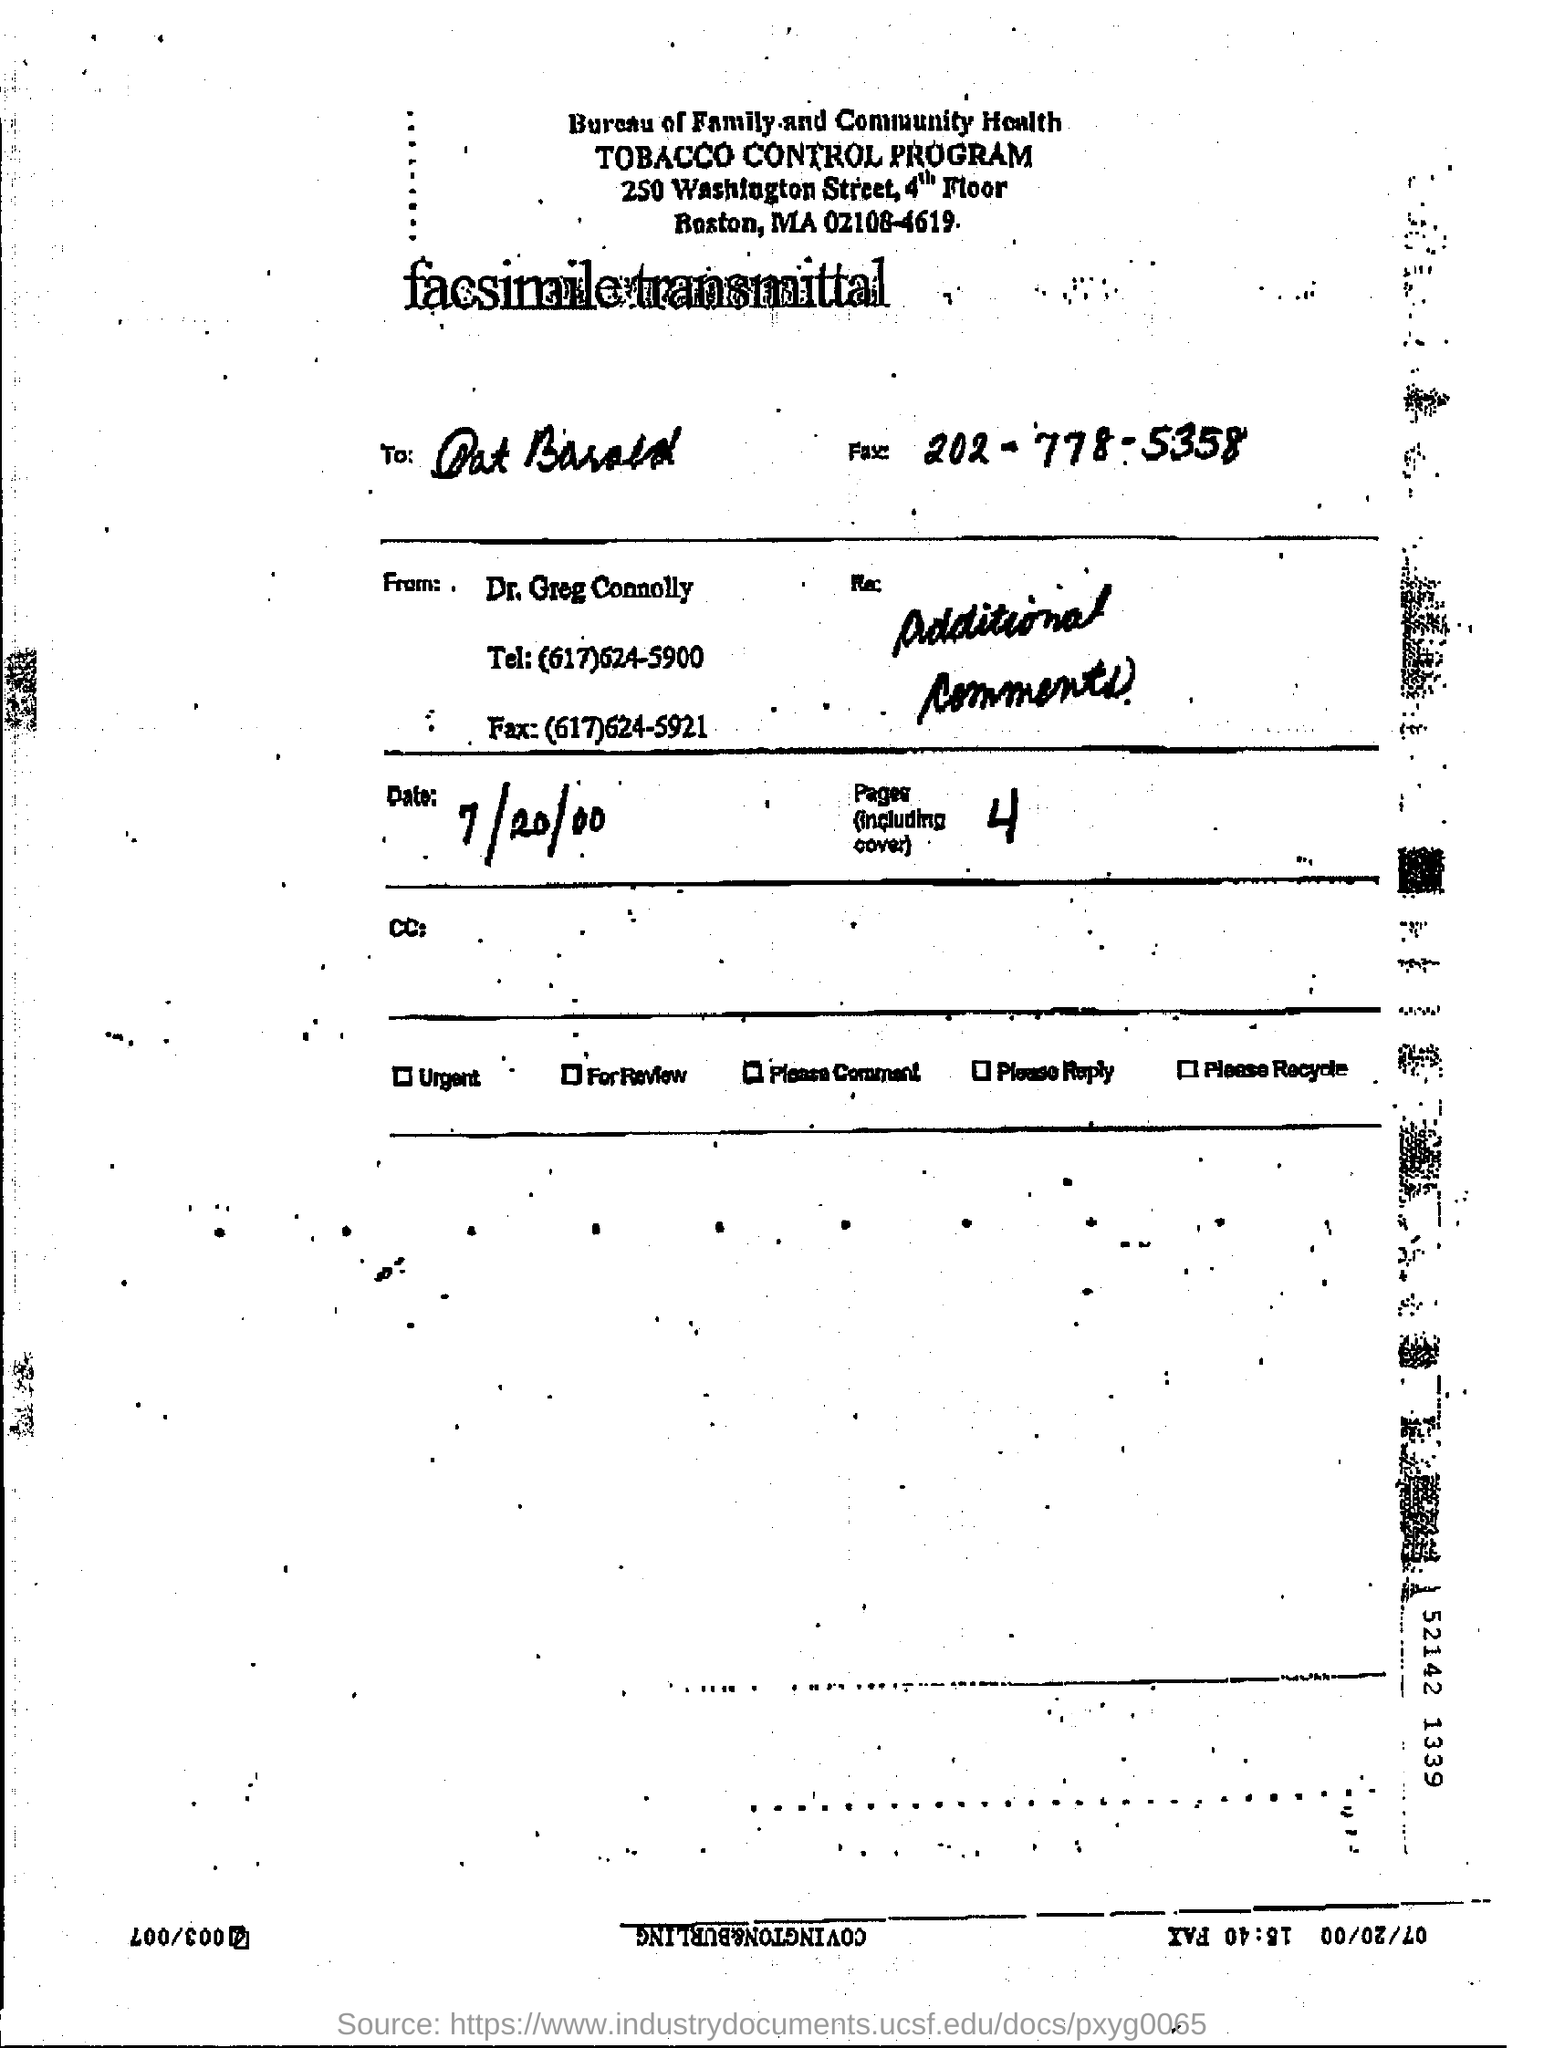Can you tell what specific type of document this is based on the image? Based on the image, this appears to be a fax sent to an individual regarding additional comments from a doctor, indicative of communication within a health program concerning tobacco control. What does the urgency indicator at the top suggest about the content? The urgency indicator not being checked suggests that the content of the fax was not considered urgent but likely needed attention for review or response. 